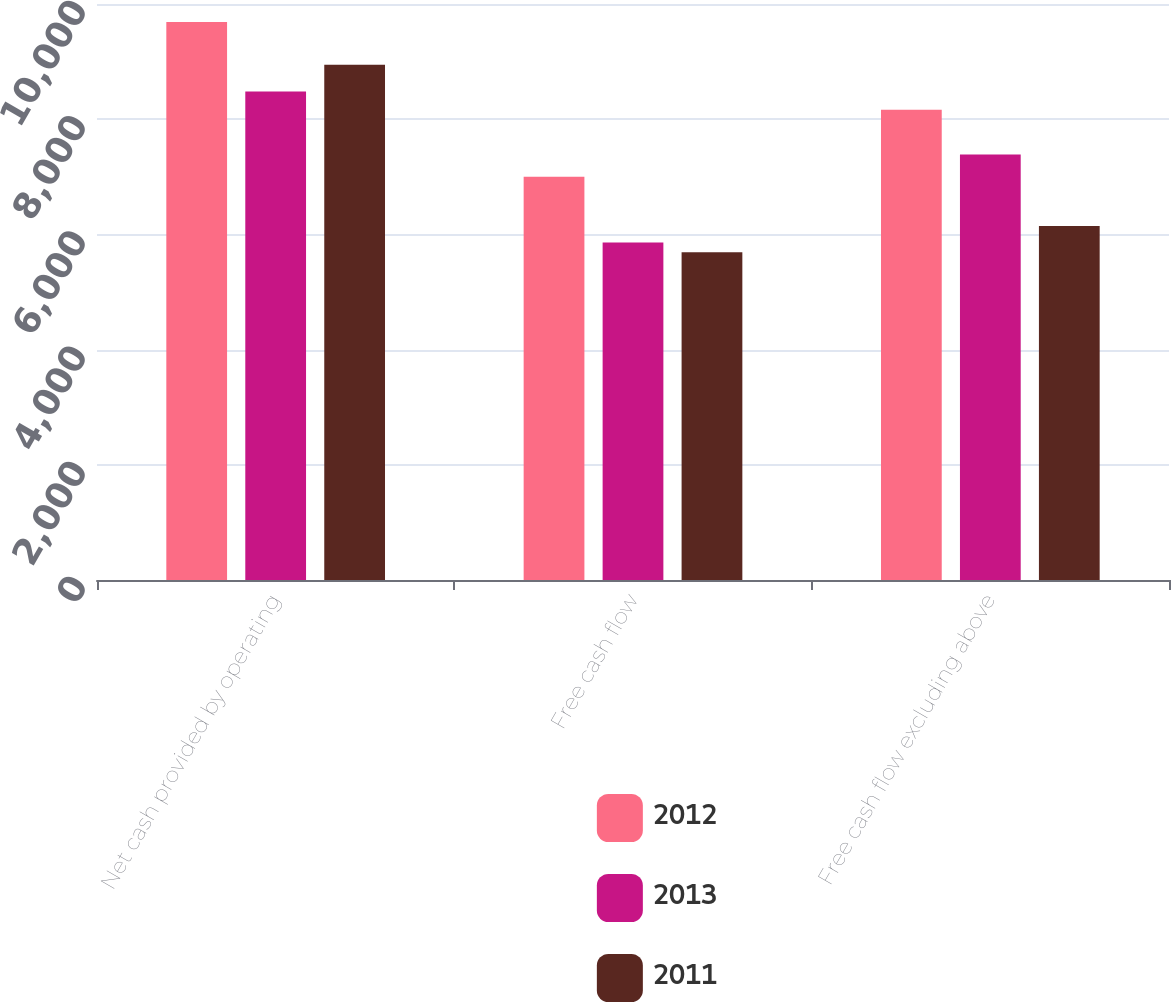Convert chart to OTSL. <chart><loc_0><loc_0><loc_500><loc_500><stacked_bar_chart><ecel><fcel>Net cash provided by operating<fcel>Free cash flow<fcel>Free cash flow excluding above<nl><fcel>2012<fcel>9688<fcel>7002<fcel>8162<nl><fcel>2013<fcel>8479<fcel>5860<fcel>7387<nl><fcel>2011<fcel>8944<fcel>5689<fcel>6145<nl></chart> 